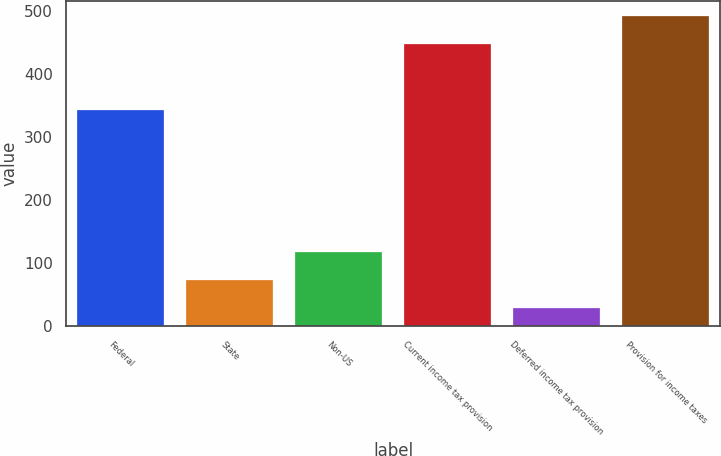Convert chart to OTSL. <chart><loc_0><loc_0><loc_500><loc_500><bar_chart><fcel>Federal<fcel>State<fcel>Non-US<fcel>Current income tax provision<fcel>Deferred income tax provision<fcel>Provision for income taxes<nl><fcel>343<fcel>73.7<fcel>118.4<fcel>447<fcel>29<fcel>491.7<nl></chart> 